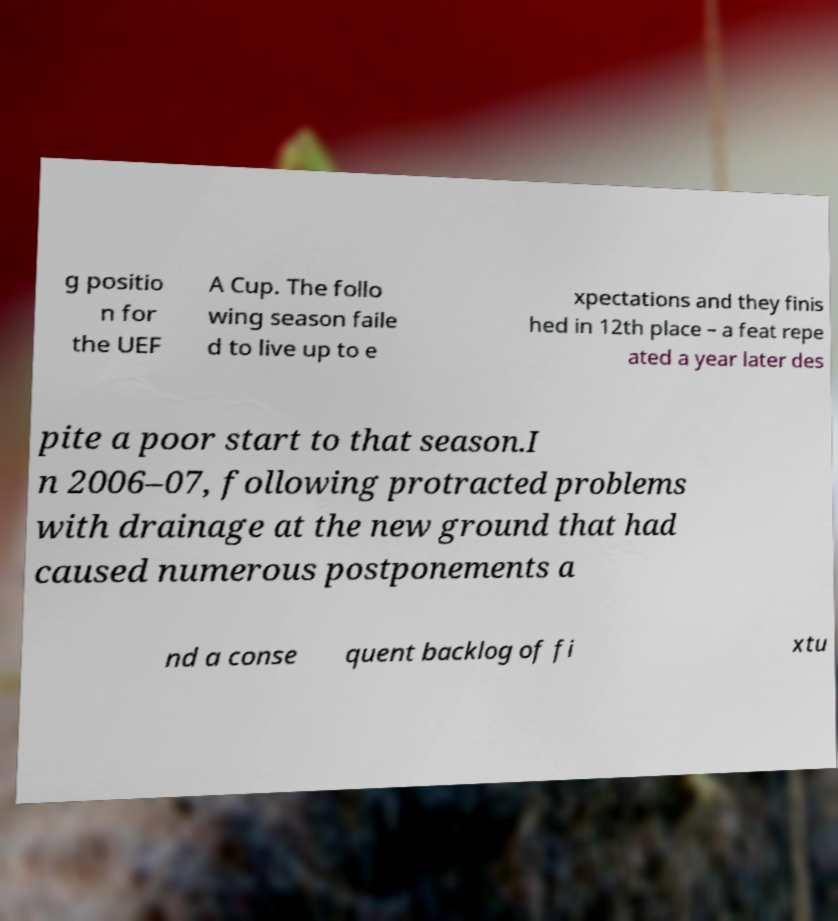What messages or text are displayed in this image? I need them in a readable, typed format. g positio n for the UEF A Cup. The follo wing season faile d to live up to e xpectations and they finis hed in 12th place – a feat repe ated a year later des pite a poor start to that season.I n 2006–07, following protracted problems with drainage at the new ground that had caused numerous postponements a nd a conse quent backlog of fi xtu 